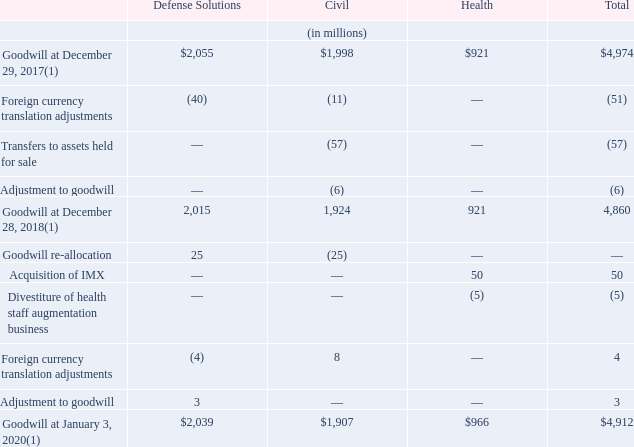Note 10—Goodwill
The following table presents changes in the carrying amount of goodwill by reportable segment:
Effective the beginning of fiscal 2019, the Company changed the composition of its Defense Solutions reportable segment, which resulted in the identification of new operating segments and reporting units within Defense Solutions. In addition, certain contracts were reassigned between the Civil and Defense Solutions reportable segments (see "Note 24—Business Segments"). Consequently, the carrying amount of goodwill was re-allocated among the reporting units for the purpose of testing goodwill for impairment.
In conjunction with the changes mentioned above, the Company evaluated goodwill for impairment using a quantitative step one analysis, both before and after the changes were made, and determined that goodwill was not impaired.
In fiscal 2019, the Company performed a qualitative analysis for all reporting units and determined that it was more likely than not that the fair values of the reporting units were in excess of the individual reporting units carrying values, and as a result, a quantitative step one analysis was not necessary.
In fiscal 2018, the Company performed a qualitative and quantitative analysis on its reporting units. Based on the qualitative analysis performed during the Company's annual impairment evaluation for fiscal 2018 for certain of its reporting units, it was determined that it was more likely than not that the fair values of the reporting units were in excess of the individual reporting unit carrying values, and as a result, a quantitative step one analysis was not necessary.
Additionally, based on the results of the quantitative step one analysis for certain other of its reporting units, it was determined that the fair value was in excess of the individual reporting units carrying values. In fiscal 2017, the Company performed a quantitative analysis for all reporting units. It was determined that the fair values of all reporting units exceeded their carrying values.
As a result, no goodwill impairments were identified as part of the annual goodwill impairment evaluation for the periods mentioned above. During the year ended January 3, 2020 and December 28, 2018, the Company recorded an immaterial correction of $3 million and $6 million, respectively, with respect to fair value of assets and liabilities acquired from the IS&GS Transactions.
(1) Carrying amount includes accumulated impairment losses of $369 million and $117 million within the Health and Civil segments, respectively.
What was the result of composition change of Defense solutions? Resulted in the identification of new operating segments and reporting units within defense solutions. What was the immaterial correction in January 2020 and December 2018? $3 million, $6 million. What was the Goodwill at December 29, 2017 under Defense Solutions, Civil and Health respectively?
Answer scale should be: million. $2,055, $1,998, $921. In which category was Goodwill at December 29, 2017 under 2,000 million? Locate and analyze goodwill at december 29, 2017(1) in row 3
answer: civil, health. What was the average Foreign currency translation adjustments?
Answer scale should be: million. -(40 + 11 + 0) / 3
Answer: -17. What was the change between total Goodwill from 2018 to 2019?
Answer scale should be: million. 4,974 - 4,860
Answer: 114. 